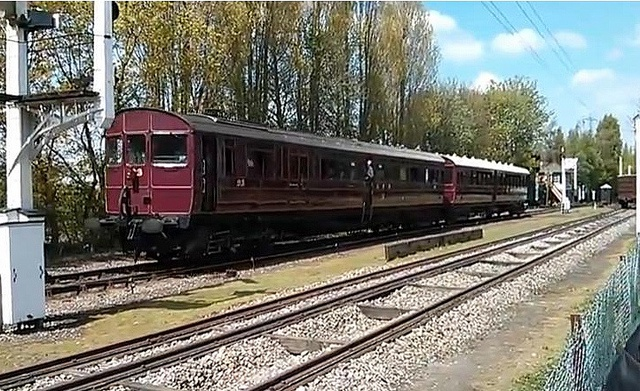Describe the objects in this image and their specific colors. I can see a train in white, black, gray, maroon, and darkgray tones in this image. 